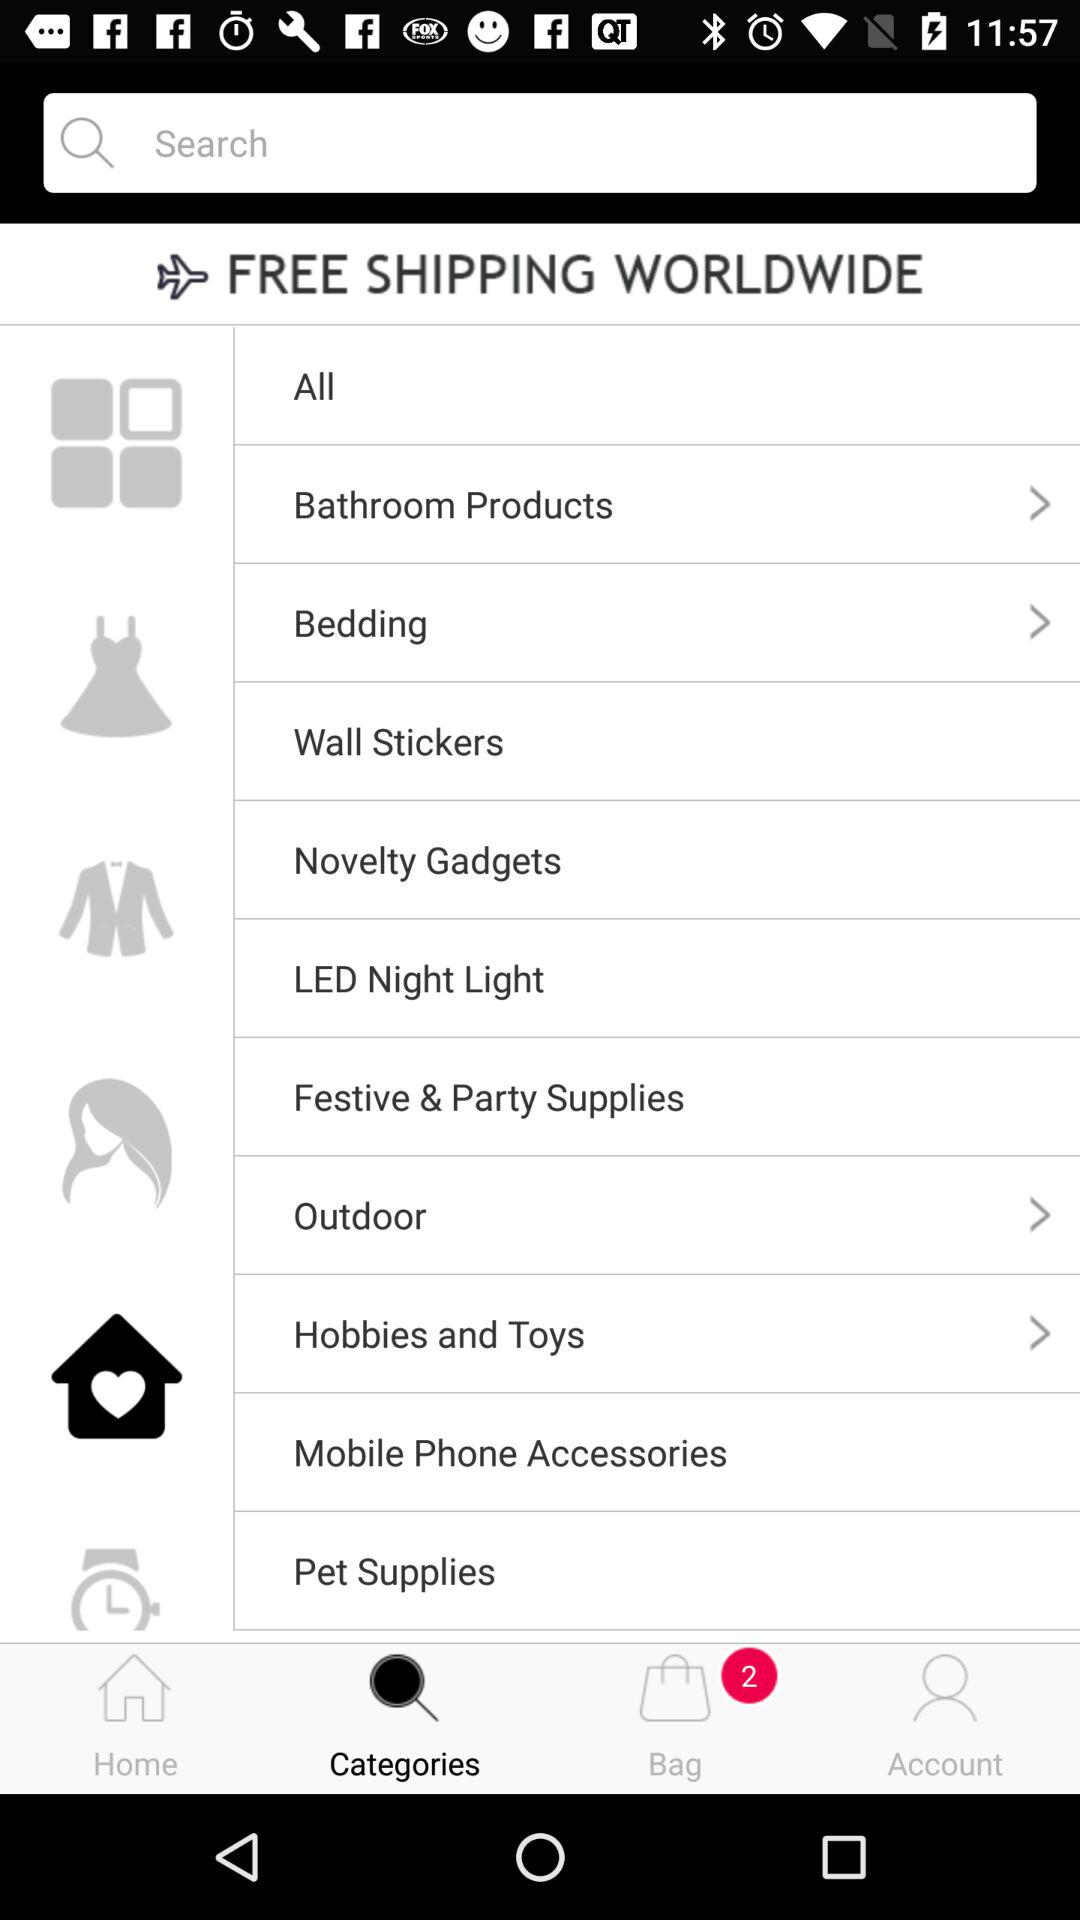How many items are in the shopping cart?
Answer the question using a single word or phrase. 2 